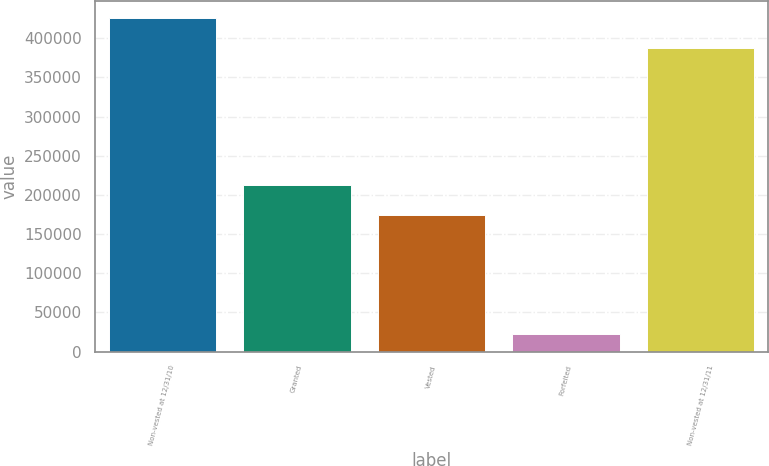Convert chart to OTSL. <chart><loc_0><loc_0><loc_500><loc_500><bar_chart><fcel>Non-vested at 12/31/10<fcel>Granted<fcel>Vested<fcel>Forfeited<fcel>Non-vested at 12/31/11<nl><fcel>425880<fcel>213213<fcel>174712<fcel>22847<fcel>387379<nl></chart> 